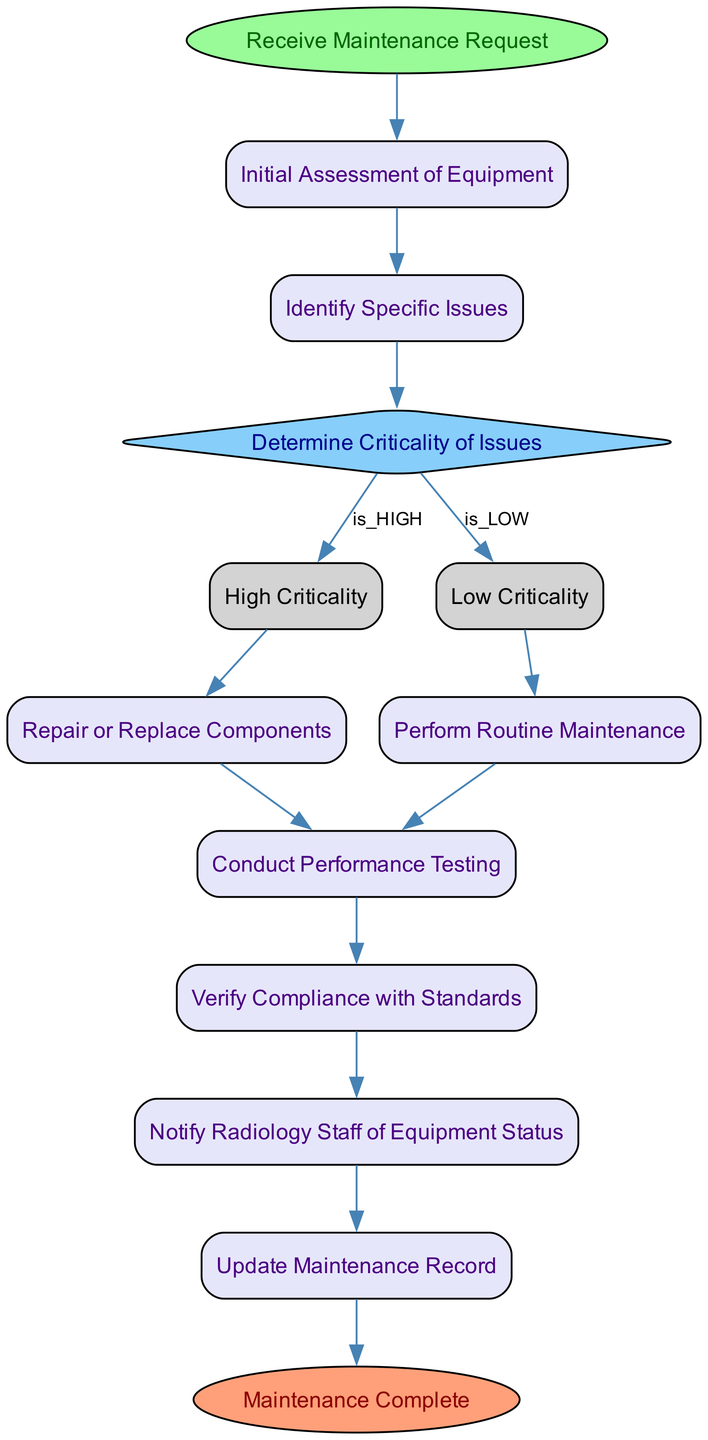What is the first activity in the diagram? The first activity in the diagram is "Receive Maintenance Request," which is labeled as the start node. This activity initiates the maintenance process.
Answer: Receive Maintenance Request How many action activities are present in the diagram? The diagram contains four action activities: "Initial Assessment of Equipment," "Perform Routine Maintenance," "Repair or Replace Components," and "Conduct Performance Testing." Counting these gives a total of four action activities.
Answer: 4 What condition leads from "Determine Criticality of Issues" to "High Criticality"? The transition from "Determine Criticality of Issues" to "High Criticality" is based on the condition "is_HIGH," indicating that if issues are deemed critical, this path will be taken.
Answer: is_HIGH What happens after "Conduct Performance Testing"? After "Conduct Performance Testing," the next step is "Verify Compliance with Standards," which ensures that the equipment meets necessary regulations and standards post-testing.
Answer: Verify Compliance with Standards Which activity follows "Notify Radiology Staff of Equipment Status"? Following "Notify Radiology Staff of Equipment Status," the next activity is "Update Maintenance Record," where the details of the maintenance performed are documented for future reference.
Answer: Update Maintenance Record What type of diagram is represented here? This diagram is an Activity Diagram, which illustrates the sequential flow of activities in a maintenance schedule process, detailing the actions and decisions involved.
Answer: Activity Diagram 